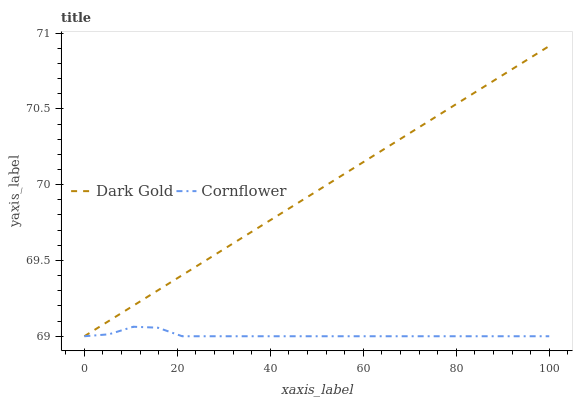Does Cornflower have the minimum area under the curve?
Answer yes or no. Yes. Does Dark Gold have the maximum area under the curve?
Answer yes or no. Yes. Does Dark Gold have the minimum area under the curve?
Answer yes or no. No. Is Dark Gold the smoothest?
Answer yes or no. Yes. Is Cornflower the roughest?
Answer yes or no. Yes. Is Dark Gold the roughest?
Answer yes or no. No. Does Cornflower have the lowest value?
Answer yes or no. Yes. Does Dark Gold have the highest value?
Answer yes or no. Yes. Does Cornflower intersect Dark Gold?
Answer yes or no. Yes. Is Cornflower less than Dark Gold?
Answer yes or no. No. Is Cornflower greater than Dark Gold?
Answer yes or no. No. 